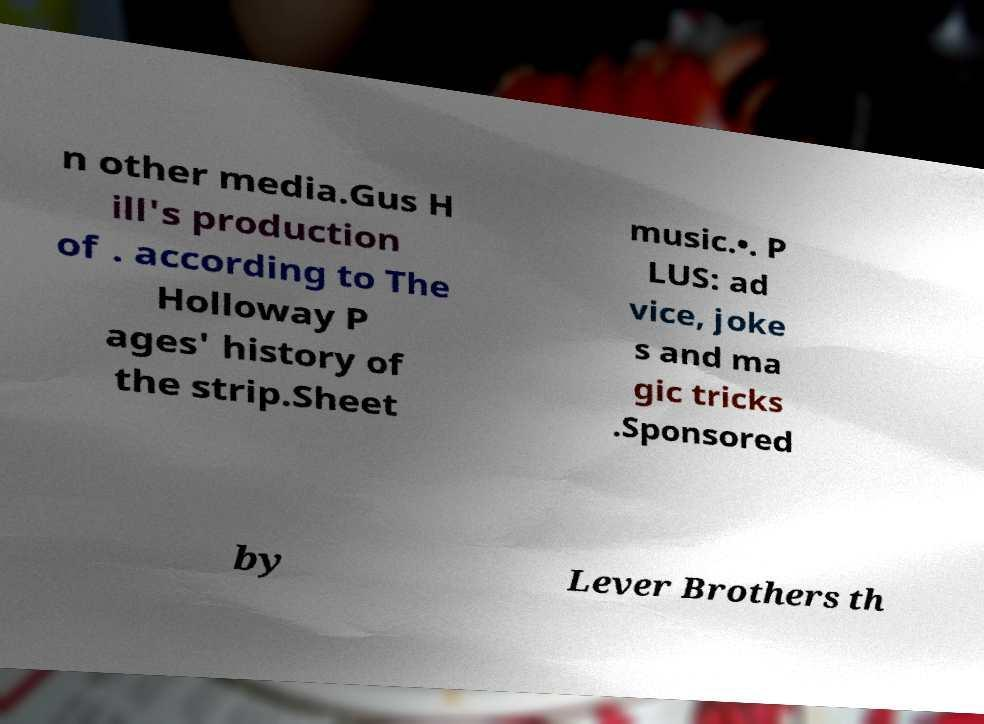Could you assist in decoding the text presented in this image and type it out clearly? n other media.Gus H ill's production of . according to The Holloway P ages' history of the strip.Sheet music.•. P LUS: ad vice, joke s and ma gic tricks .Sponsored by Lever Brothers th 